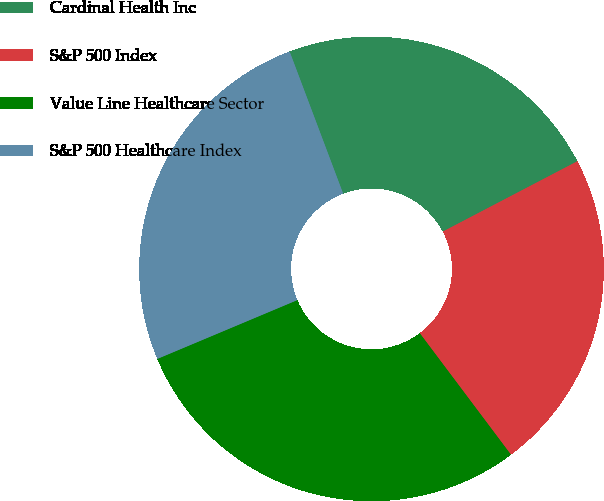<chart> <loc_0><loc_0><loc_500><loc_500><pie_chart><fcel>Cardinal Health Inc<fcel>S&P 500 Index<fcel>Value Line Healthcare Sector<fcel>S&P 500 Healthcare Index<nl><fcel>23.07%<fcel>22.42%<fcel>28.92%<fcel>25.6%<nl></chart> 